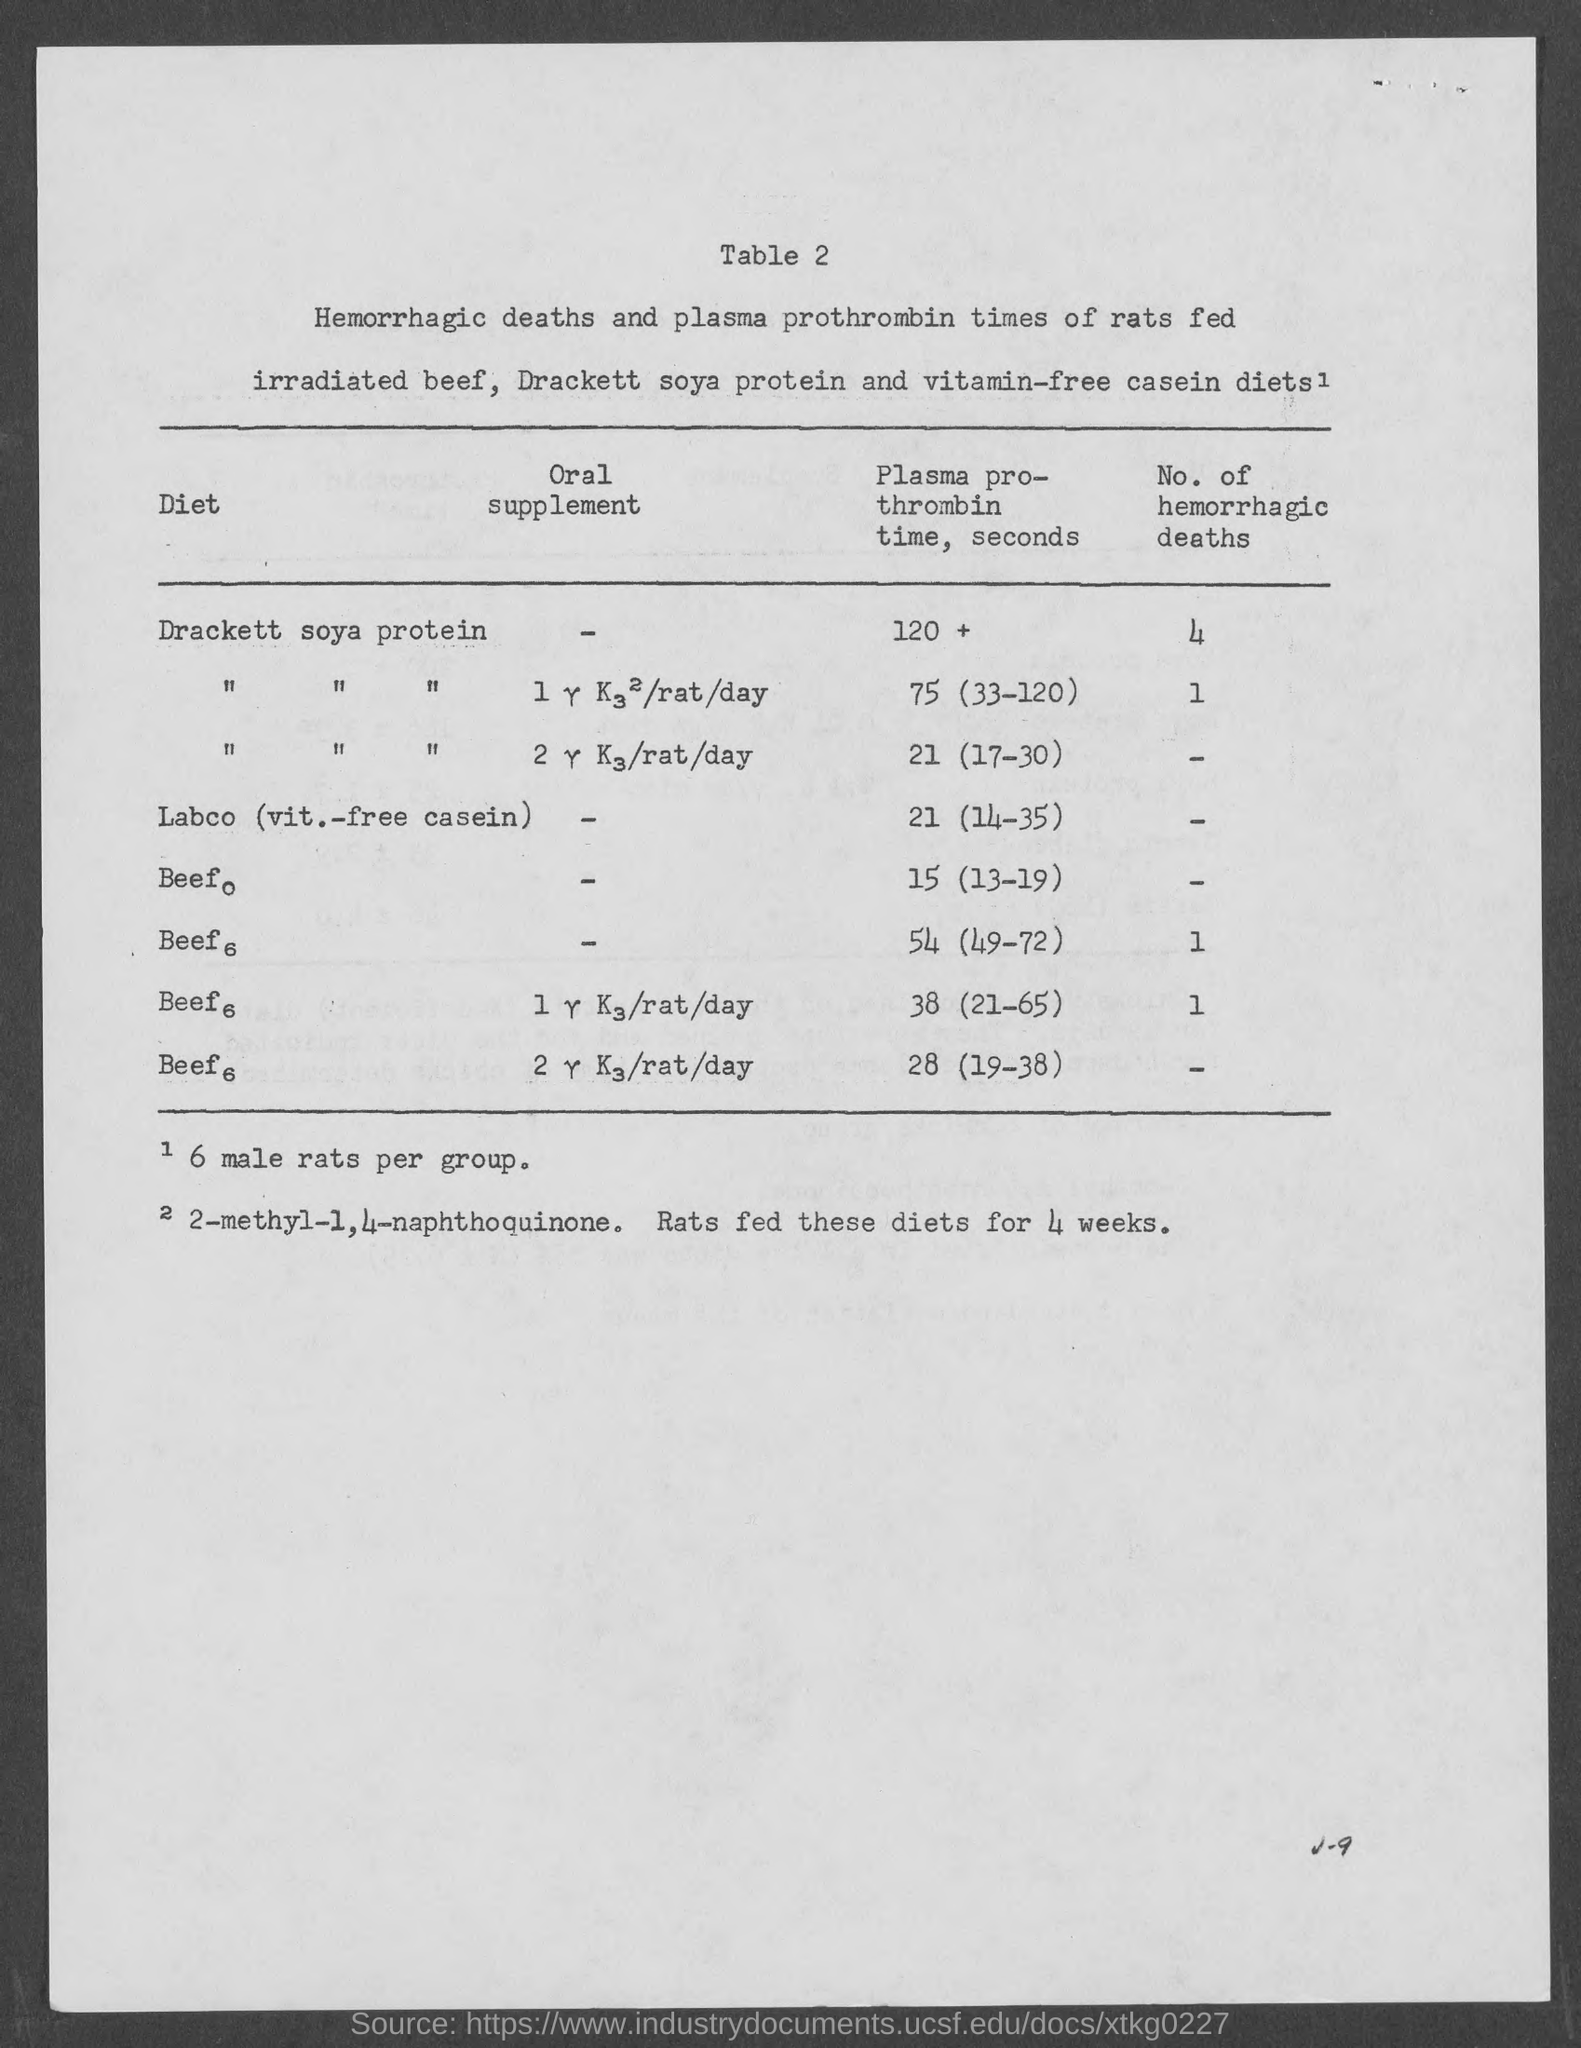What is the table number?
Offer a terse response. 2. What is the title of the first column of the table?
Your response must be concise. Diet. What is the number of hemorrhagic deaths due to Drackett's soya protein?
Provide a short and direct response. 4. 